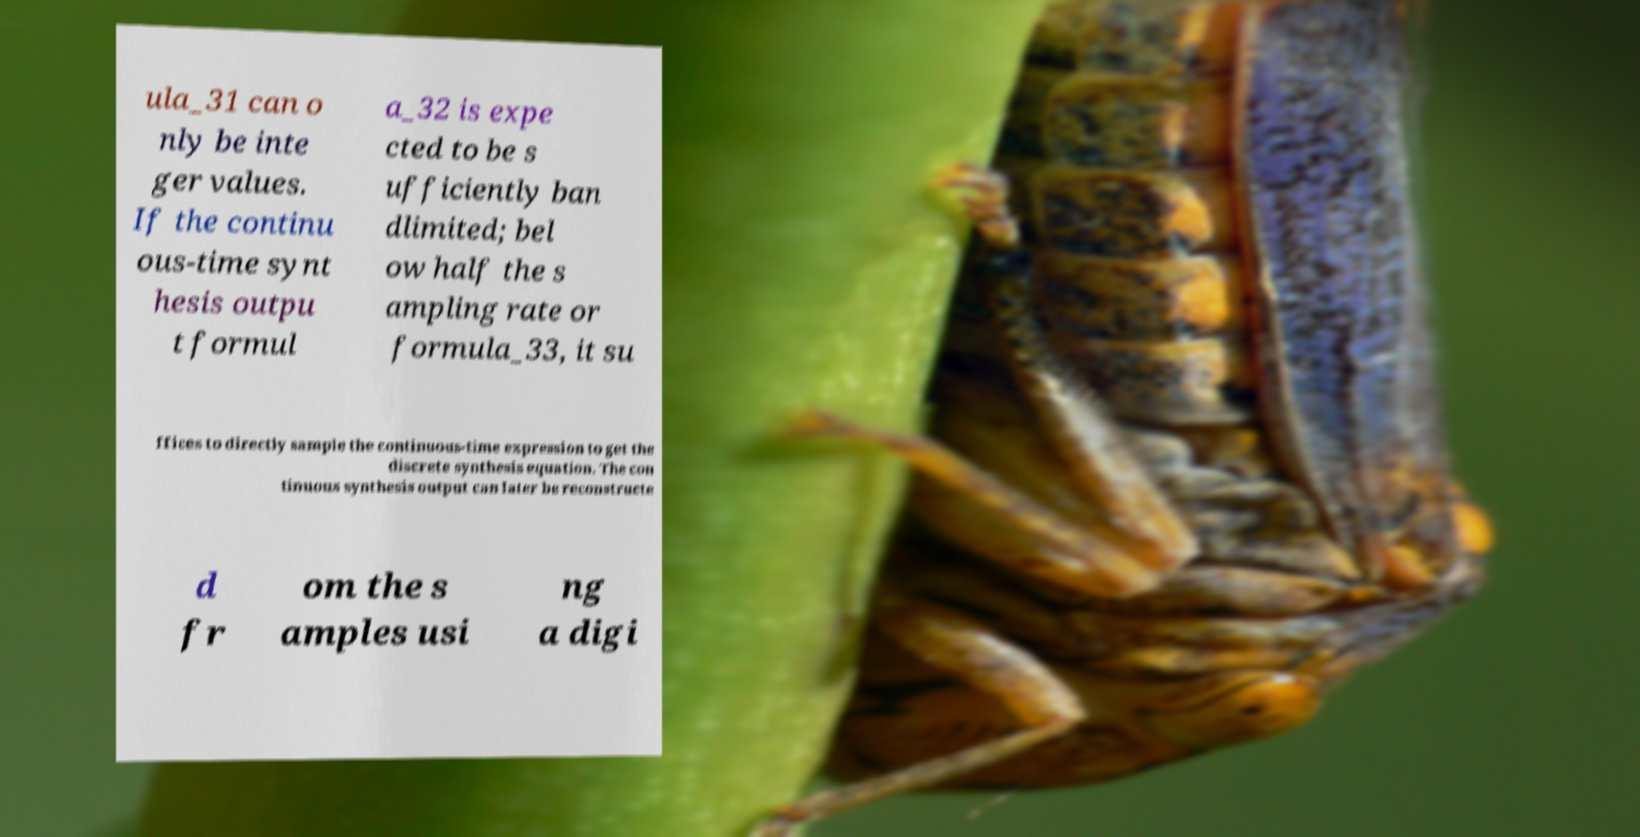Please read and relay the text visible in this image. What does it say? ula_31 can o nly be inte ger values. If the continu ous-time synt hesis outpu t formul a_32 is expe cted to be s ufficiently ban dlimited; bel ow half the s ampling rate or formula_33, it su ffices to directly sample the continuous-time expression to get the discrete synthesis equation. The con tinuous synthesis output can later be reconstructe d fr om the s amples usi ng a digi 